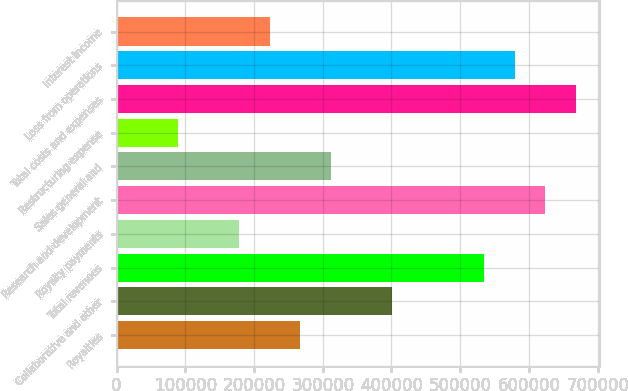<chart> <loc_0><loc_0><loc_500><loc_500><bar_chart><fcel>Royalties<fcel>Collaborative and other<fcel>Total revenues<fcel>Royalty payments<fcel>Research and development<fcel>Sales general and<fcel>Restructuring expense<fcel>Total costs and expenses<fcel>Loss from operations<fcel>Interest income<nl><fcel>267237<fcel>400855<fcel>534472<fcel>178159<fcel>623551<fcel>311776<fcel>89080.3<fcel>668090<fcel>579012<fcel>222698<nl></chart> 